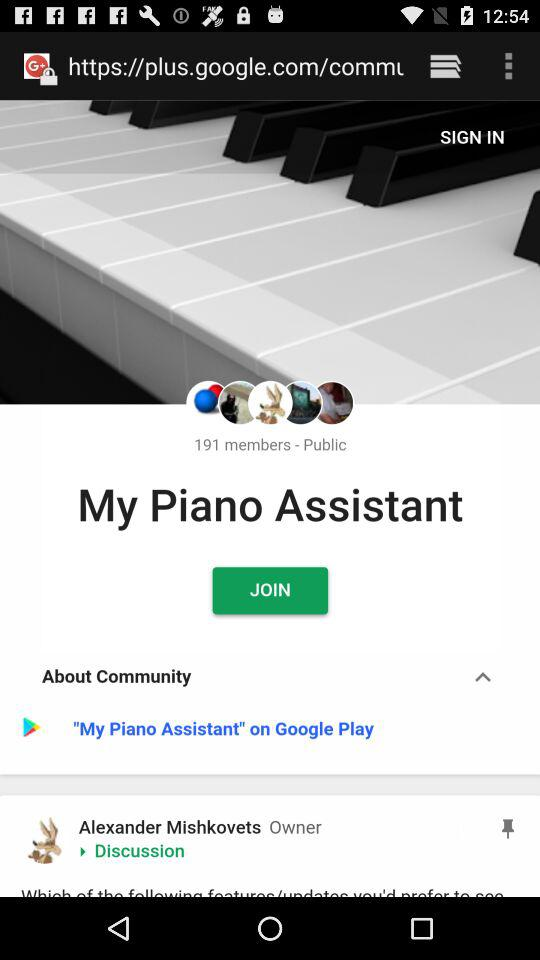What is the privacy setting of "My Piano Assistant"? The privacy setting is "Public". 